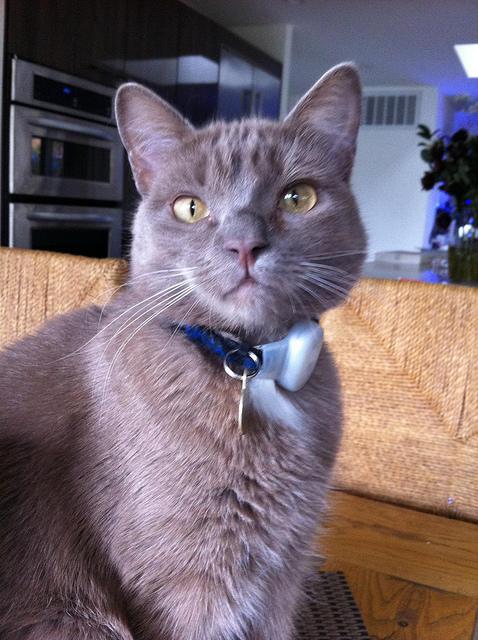What is around the cats neck?
Answer briefly. Collar. What color is the cat's eyes?
Answer briefly. Yellow. What room is the cat in?
Write a very short answer. Kitchen. 